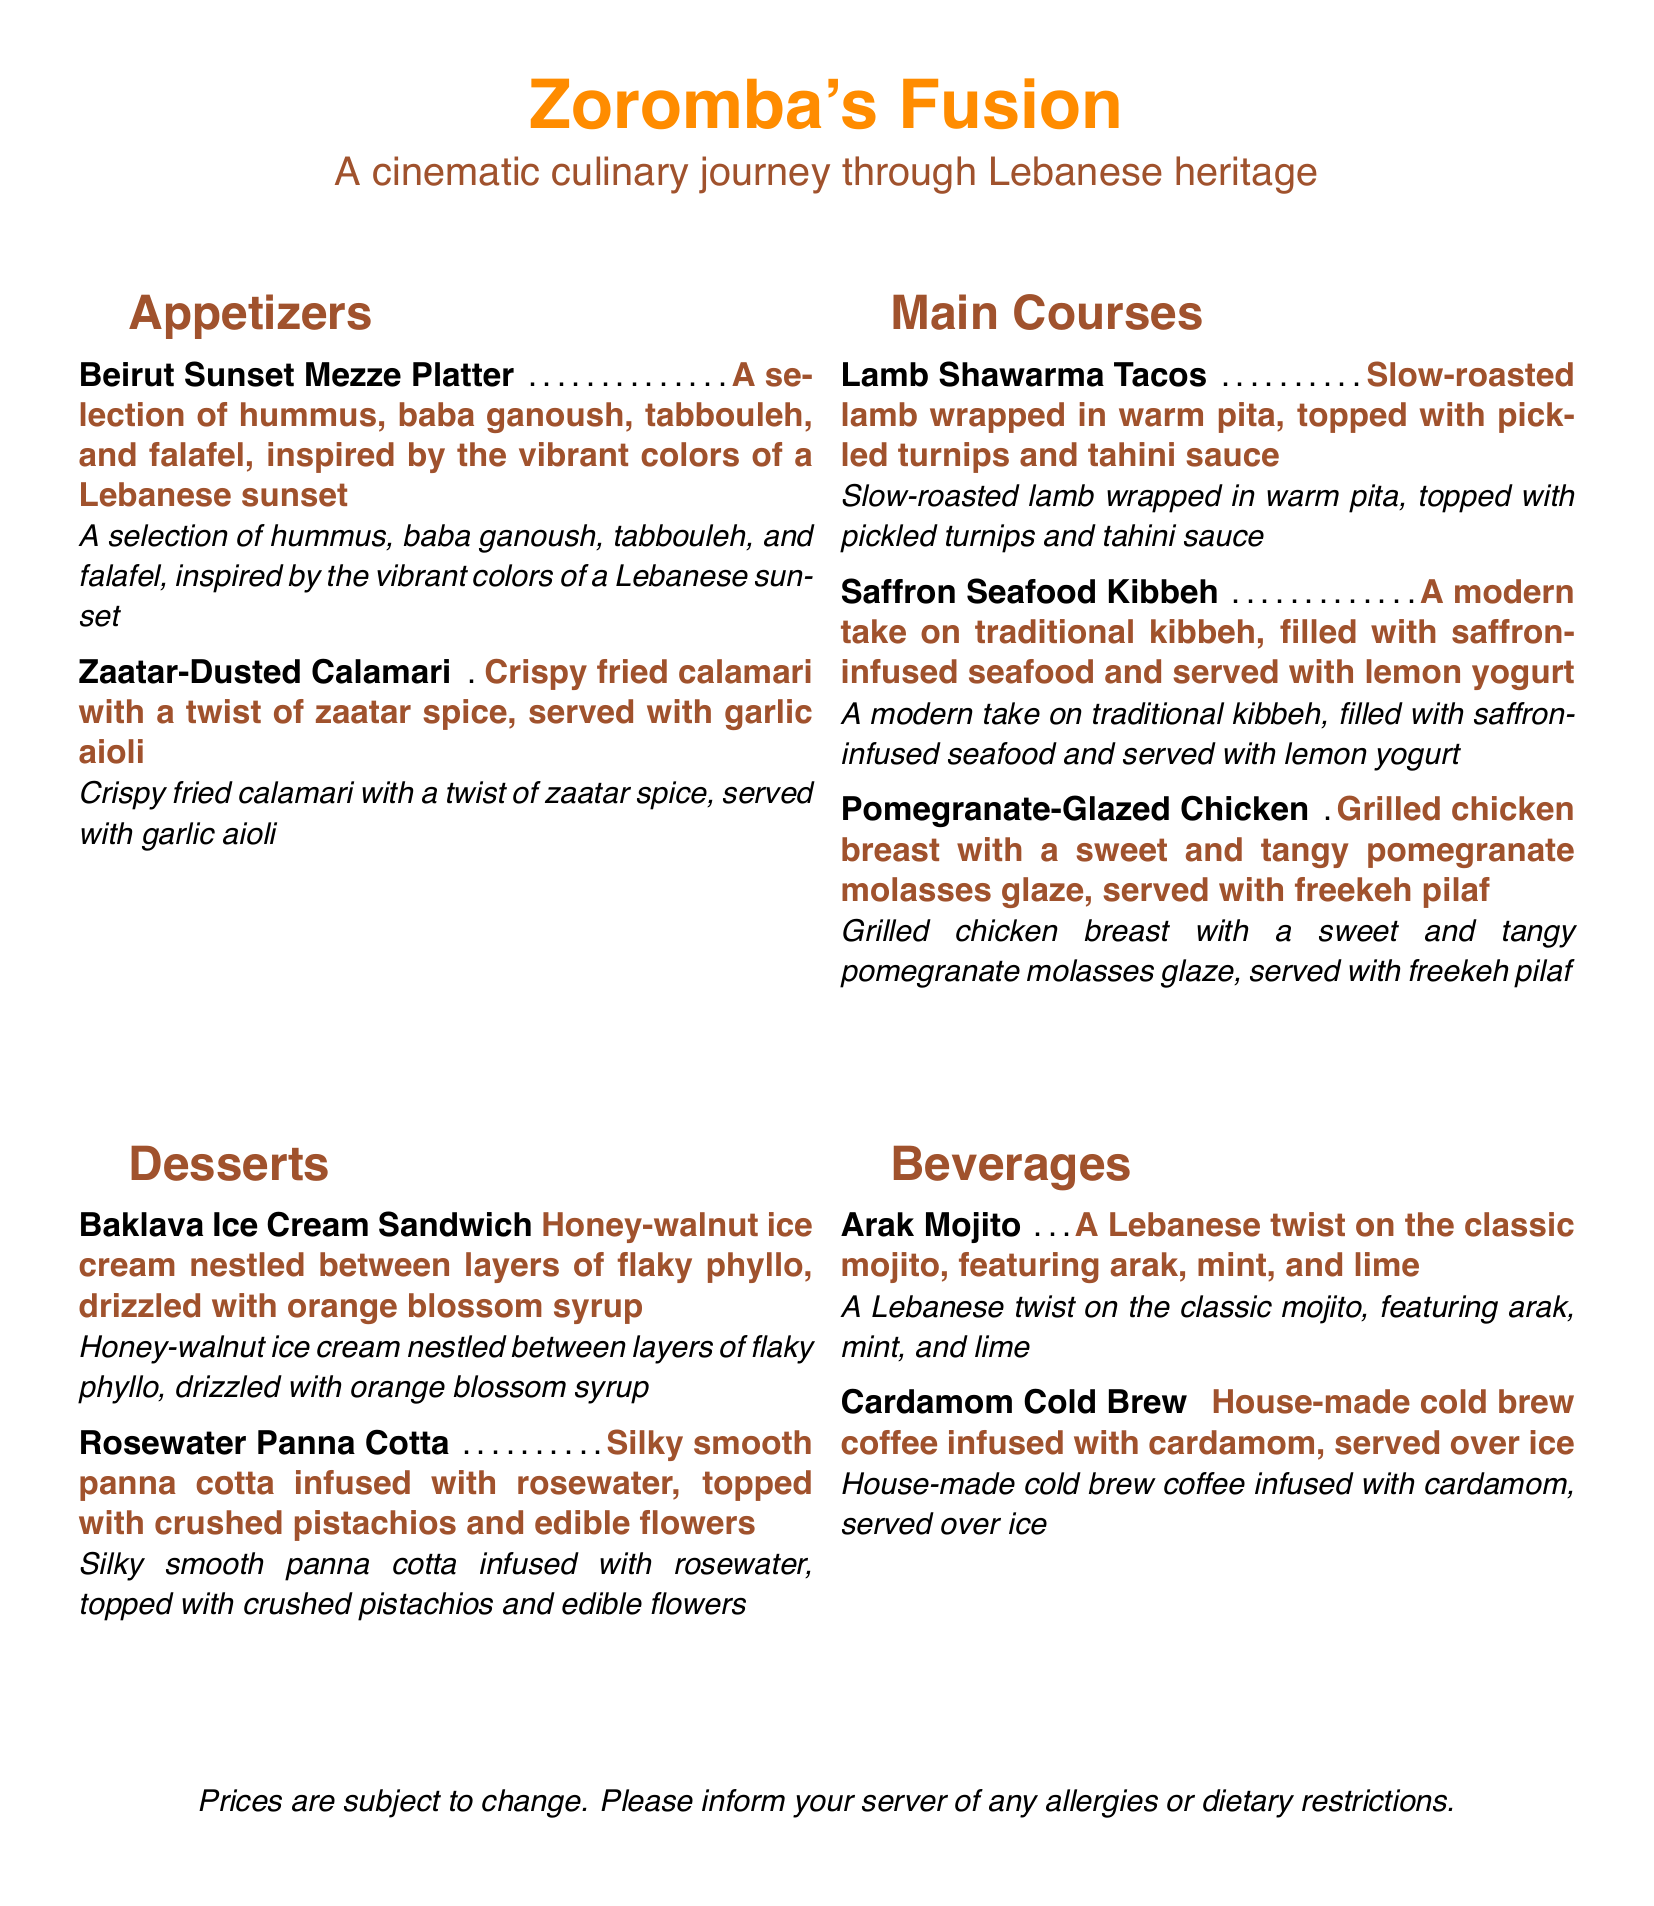what is the name of the restaurant? The restaurant's name is prominently displayed at the top of the menu.
Answer: Zoromba's Fusion what is the theme of the menu? The theme is explicitly stated under the restaurant name, indicating its focus.
Answer: A cinematic culinary journey through Lebanese heritage how many appetizers are listed on the menu? The menu features a section dedicated to appetizers with a specific number presented.
Answer: 2 what is the price for the Beirut Sunset Mezze Platter? The price is indicated next to the item in the menu format.
Answer: Not specified name one of the main courses that includes pomegranate. The menu lists various main courses, and one specifically mentions pomegranate.
Answer: Pomegranate-Glazed Chicken which beverage features arak? The menu includes beverages with specific names and ingredients, one of which includes arak.
Answer: Arak Mojito what unique ingredient is used in the Rosewater Panna Cotta? The ingredient is highlighted in the dessert description of the menu.
Answer: Rosewater how is the Lamb Shawarma presented? The presentation details are provided in the description of the dish on the menu.
Answer: Wrapped in warm pita what dessert is described as a sandwich? The menu describes various desserts, including one that is a sandwich type.
Answer: Baklava Ice Cream Sandwich 